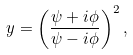Convert formula to latex. <formula><loc_0><loc_0><loc_500><loc_500>y = \left ( \frac { \psi + i \phi } { \psi - i \phi } \right ) ^ { 2 } ,</formula> 